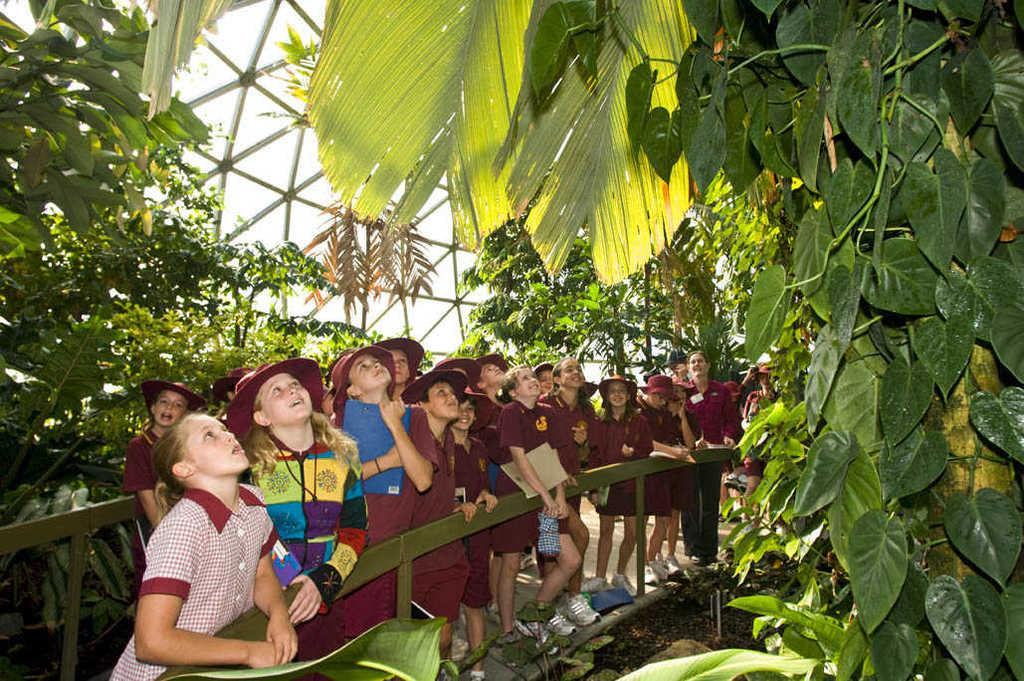What is the main subject of the image? The main subject of the image is a group of children. Where are the children located in the image? The children are standing on a path in the image. What is the facial expression of the children? The children are smiling in the image. What can be seen in the background of the image? There are trees, rods, and the sky visible in the background of the image. What type of day is depicted in the image? The text does not provide any information about the day or time of day, so it cannot be determined from the image. 